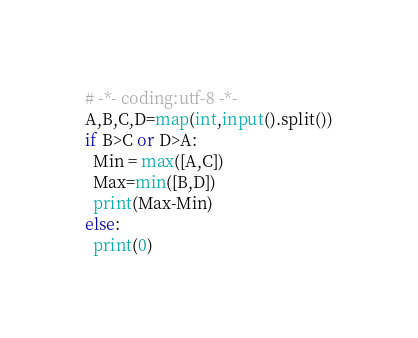<code> <loc_0><loc_0><loc_500><loc_500><_Python_># -*- coding:utf-8 -*-
A,B,C,D=map(int,input().split())
if B>C or D>A:
  Min = max([A,C])
  Max=min([B,D])
  print(Max-Min)
else:
  print(0)</code> 